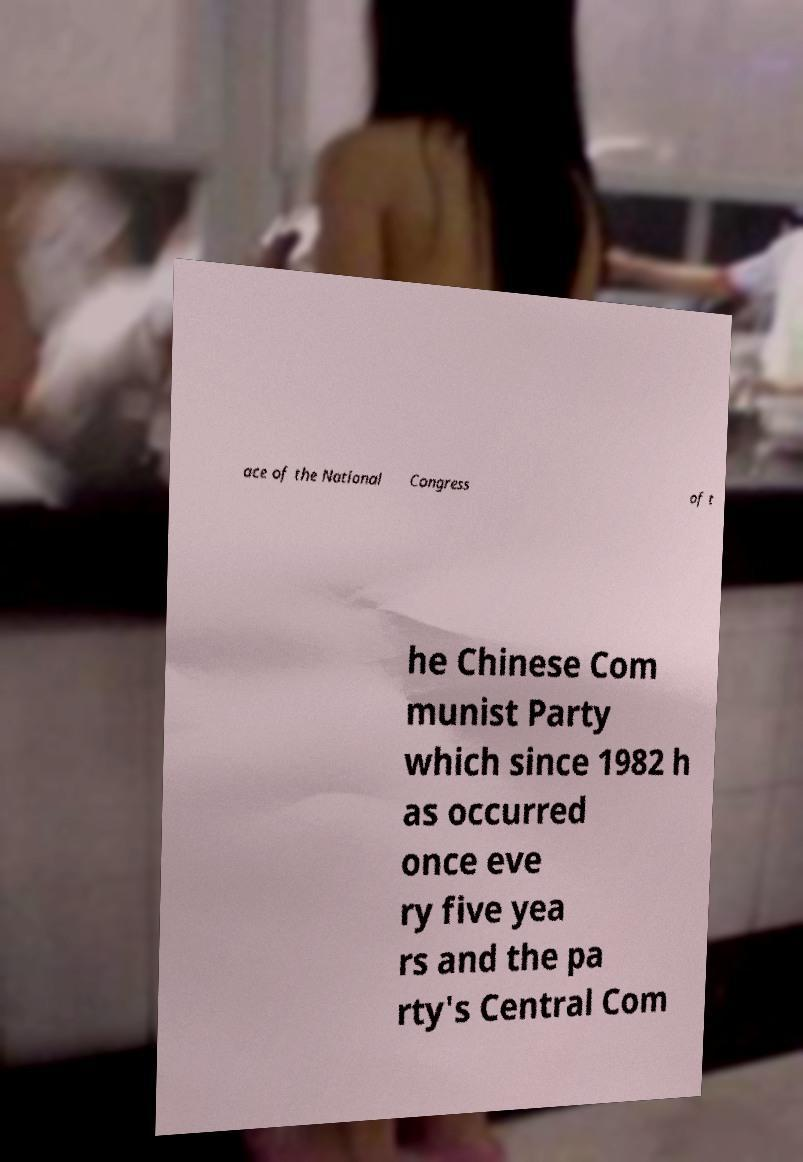Please identify and transcribe the text found in this image. ace of the National Congress of t he Chinese Com munist Party which since 1982 h as occurred once eve ry five yea rs and the pa rty's Central Com 